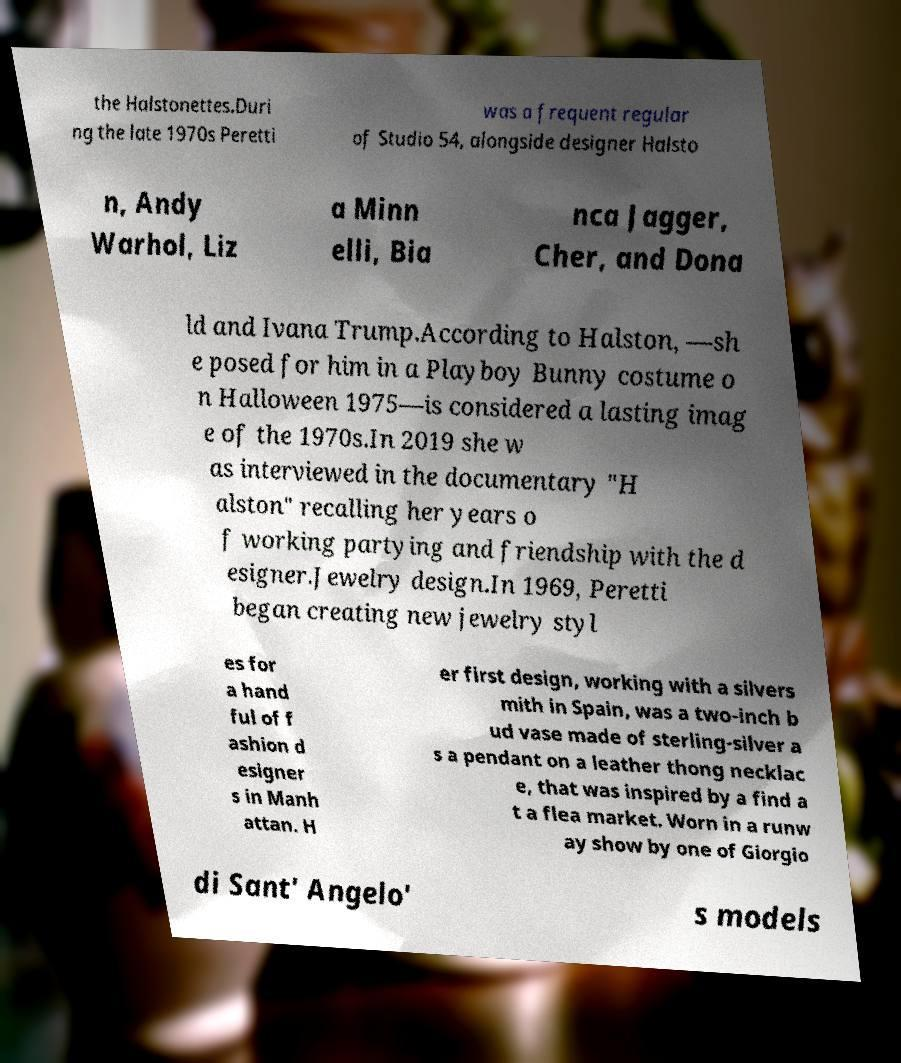Could you assist in decoding the text presented in this image and type it out clearly? the Halstonettes.Duri ng the late 1970s Peretti was a frequent regular of Studio 54, alongside designer Halsto n, Andy Warhol, Liz a Minn elli, Bia nca Jagger, Cher, and Dona ld and Ivana Trump.According to Halston, —sh e posed for him in a Playboy Bunny costume o n Halloween 1975—is considered a lasting imag e of the 1970s.In 2019 she w as interviewed in the documentary "H alston" recalling her years o f working partying and friendship with the d esigner.Jewelry design.In 1969, Peretti began creating new jewelry styl es for a hand ful of f ashion d esigner s in Manh attan. H er first design, working with a silvers mith in Spain, was a two-inch b ud vase made of sterling-silver a s a pendant on a leather thong necklac e, that was inspired by a find a t a flea market. Worn in a runw ay show by one of Giorgio di Sant' Angelo' s models 